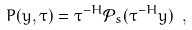Convert formula to latex. <formula><loc_0><loc_0><loc_500><loc_500>P ( y , \tau ) = \tau ^ { - H } \mathcal { P } _ { s } ( \tau ^ { - H } y ) \ ,</formula> 